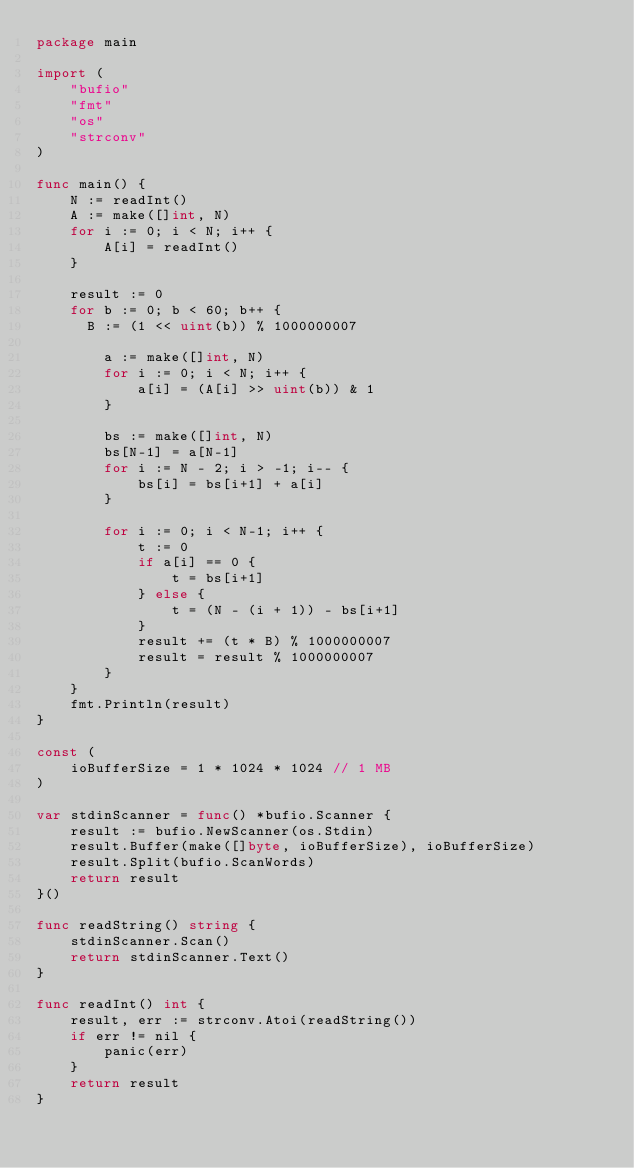<code> <loc_0><loc_0><loc_500><loc_500><_Go_>package main

import (
	"bufio"
	"fmt"
	"os"
	"strconv"
)

func main() {
	N := readInt()
	A := make([]int, N)
	for i := 0; i < N; i++ {
		A[i] = readInt()
	}

	result := 0
	for b := 0; b < 60; b++ {
      B := (1 << uint(b)) % 1000000007

		a := make([]int, N)
		for i := 0; i < N; i++ {
			a[i] = (A[i] >> uint(b)) & 1
		}

		bs := make([]int, N)
		bs[N-1] = a[N-1]
		for i := N - 2; i > -1; i-- {
			bs[i] = bs[i+1] + a[i]
		}

		for i := 0; i < N-1; i++ {
			t := 0
			if a[i] == 0 {
				t = bs[i+1]
			} else {
				t = (N - (i + 1)) - bs[i+1]
			}
			result += (t * B) % 1000000007
			result = result % 1000000007
		}
	}
	fmt.Println(result)
}

const (
	ioBufferSize = 1 * 1024 * 1024 // 1 MB
)

var stdinScanner = func() *bufio.Scanner {
	result := bufio.NewScanner(os.Stdin)
	result.Buffer(make([]byte, ioBufferSize), ioBufferSize)
	result.Split(bufio.ScanWords)
	return result
}()

func readString() string {
	stdinScanner.Scan()
	return stdinScanner.Text()
}

func readInt() int {
	result, err := strconv.Atoi(readString())
	if err != nil {
		panic(err)
	}
	return result
}
</code> 